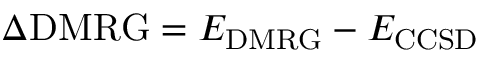<formula> <loc_0><loc_0><loc_500><loc_500>\Delta D M R G = E _ { D M R G } - E _ { C C S D }</formula> 